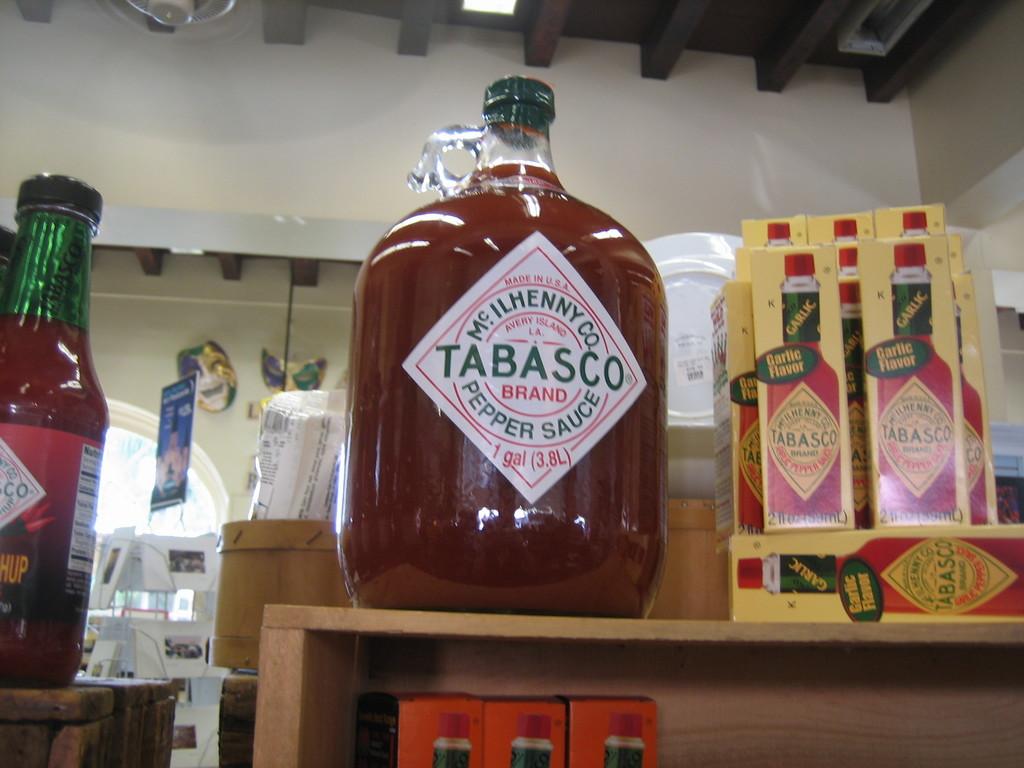What type of sauce is this?
Make the answer very short. Tabasco. 